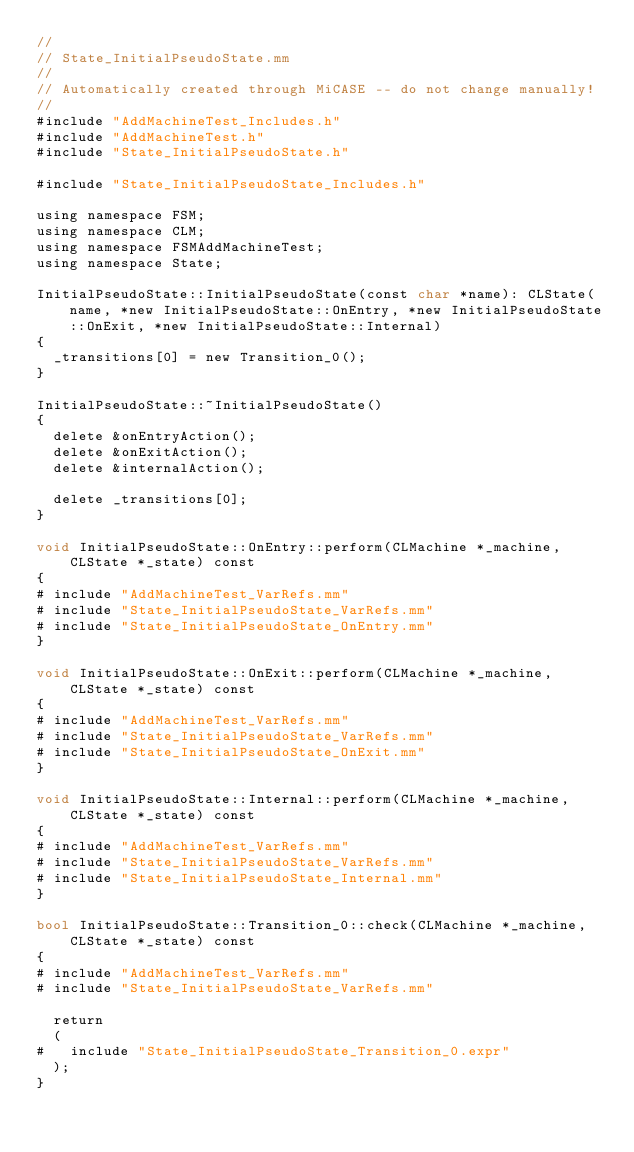Convert code to text. <code><loc_0><loc_0><loc_500><loc_500><_ObjectiveC_>//
// State_InitialPseudoState.mm
//
// Automatically created through MiCASE -- do not change manually!
//
#include "AddMachineTest_Includes.h"
#include "AddMachineTest.h"
#include "State_InitialPseudoState.h"

#include "State_InitialPseudoState_Includes.h"

using namespace FSM;
using namespace CLM;
using namespace FSMAddMachineTest;
using namespace State;

InitialPseudoState::InitialPseudoState(const char *name): CLState(name, *new InitialPseudoState::OnEntry, *new InitialPseudoState::OnExit, *new InitialPseudoState::Internal)
{
	_transitions[0] = new Transition_0();
}

InitialPseudoState::~InitialPseudoState()
{
	delete &onEntryAction();
	delete &onExitAction();
	delete &internalAction();

	delete _transitions[0];
}

void InitialPseudoState::OnEntry::perform(CLMachine *_machine, CLState *_state) const
{
#	include "AddMachineTest_VarRefs.mm"
#	include "State_InitialPseudoState_VarRefs.mm"
#	include "State_InitialPseudoState_OnEntry.mm"
}

void InitialPseudoState::OnExit::perform(CLMachine *_machine, CLState *_state) const
{
#	include "AddMachineTest_VarRefs.mm"
#	include "State_InitialPseudoState_VarRefs.mm"
#	include "State_InitialPseudoState_OnExit.mm"
}

void InitialPseudoState::Internal::perform(CLMachine *_machine, CLState *_state) const
{
#	include "AddMachineTest_VarRefs.mm"
#	include "State_InitialPseudoState_VarRefs.mm"
#	include "State_InitialPseudoState_Internal.mm"
}

bool InitialPseudoState::Transition_0::check(CLMachine *_machine, CLState *_state) const
{
#	include "AddMachineTest_VarRefs.mm"
#	include "State_InitialPseudoState_VarRefs.mm"

	return
	(
#		include "State_InitialPseudoState_Transition_0.expr"
	);
}
</code> 